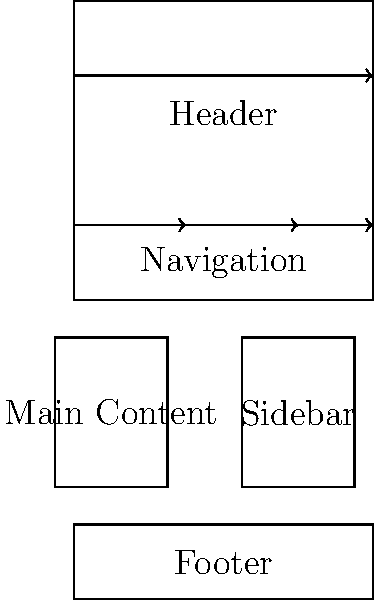Based on the visual hierarchy diagram for a website layout, which element should receive the most visual emphasis to effectively guide users' attention? To determine the element that should receive the most visual emphasis in this website layout, we need to consider the principles of visual hierarchy and user experience design:

1. Position: Elements at the top of the page typically receive more attention.
2. Size: Larger elements are more prominent and draw more attention.
3. Purpose: The main purpose of the website should be highlighted.
4. User flow: Consider how users typically navigate a website.

Analyzing the diagram:

1. The Header is positioned at the top and spans the full width, making it highly visible.
2. The Navigation bar is directly below the header, indicating its importance for site navigation.
3. The Main Content area is larger than the Sidebar, suggesting it contains the primary information.
4. The arrow flow indicates a top-to-bottom, left-to-right reading pattern.

Given these factors, the Header should receive the most visual emphasis because:
a) It's positioned at the top, making it the first element users see.
b) It spans the full width, allowing for prominent branding and key information.
c) It sets the tone for the entire website and often contains crucial elements like logo and main call-to-action.
d) It guides users to the navigation and main content areas.

For an entrepreneur with a great business idea but lacking design skills, emphasizing the Header is crucial as it's often the first impression users have of the business and can significantly impact user engagement and conversion rates.
Answer: Header 